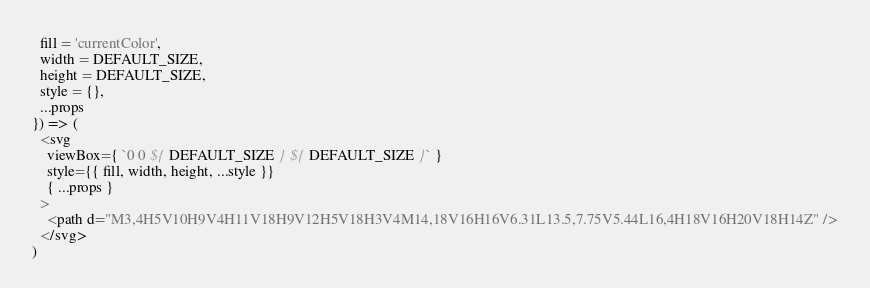Convert code to text. <code><loc_0><loc_0><loc_500><loc_500><_JavaScript_>  fill = 'currentColor',
  width = DEFAULT_SIZE,
  height = DEFAULT_SIZE,
  style = {},
  ...props
}) => (
  <svg
    viewBox={ `0 0 ${ DEFAULT_SIZE } ${ DEFAULT_SIZE }` }
    style={{ fill, width, height, ...style }}
    { ...props }
  >
    <path d="M3,4H5V10H9V4H11V18H9V12H5V18H3V4M14,18V16H16V6.31L13.5,7.75V5.44L16,4H18V16H20V18H14Z" />
  </svg>
)
</code> 